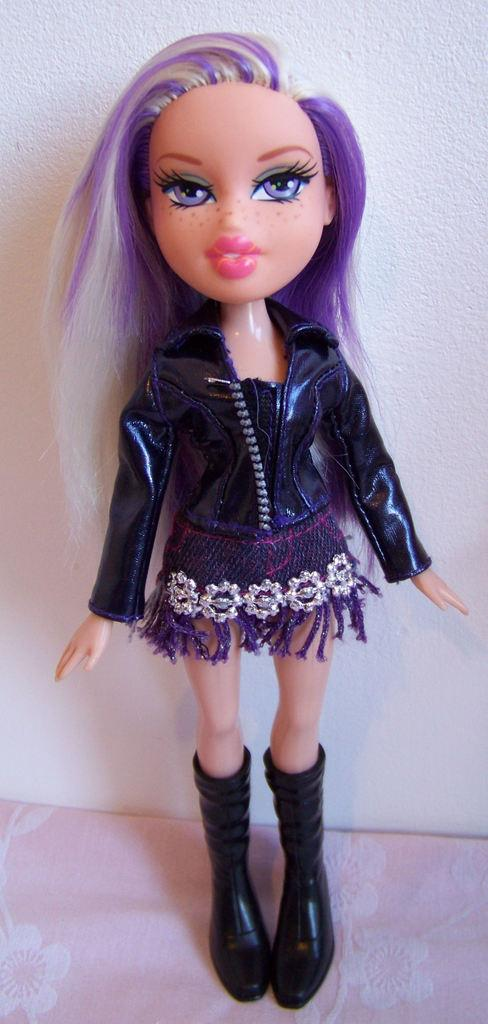What object can be seen in the image? There is a toy in the image. What type of bone can be seen in the image? There is no bone present in the image; it only features a toy. How does the fog affect the visibility of the toy in the image? There is no fog present in the image, so it does not affect the visibility of the toy. 